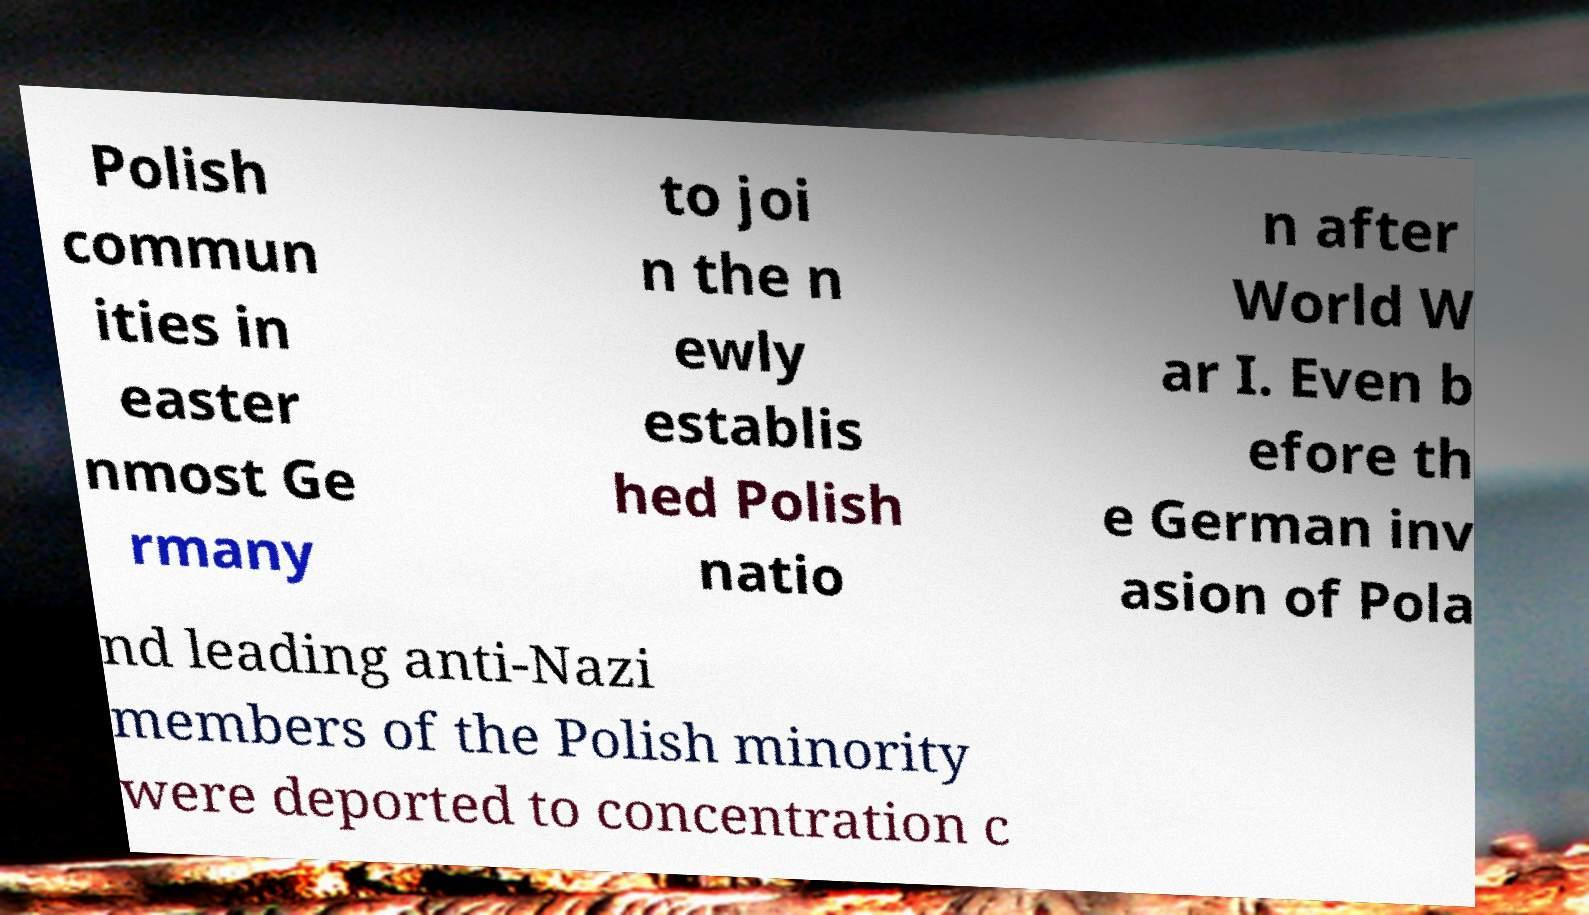Can you read and provide the text displayed in the image?This photo seems to have some interesting text. Can you extract and type it out for me? Polish commun ities in easter nmost Ge rmany to joi n the n ewly establis hed Polish natio n after World W ar I. Even b efore th e German inv asion of Pola nd leading anti-Nazi members of the Polish minority were deported to concentration c 